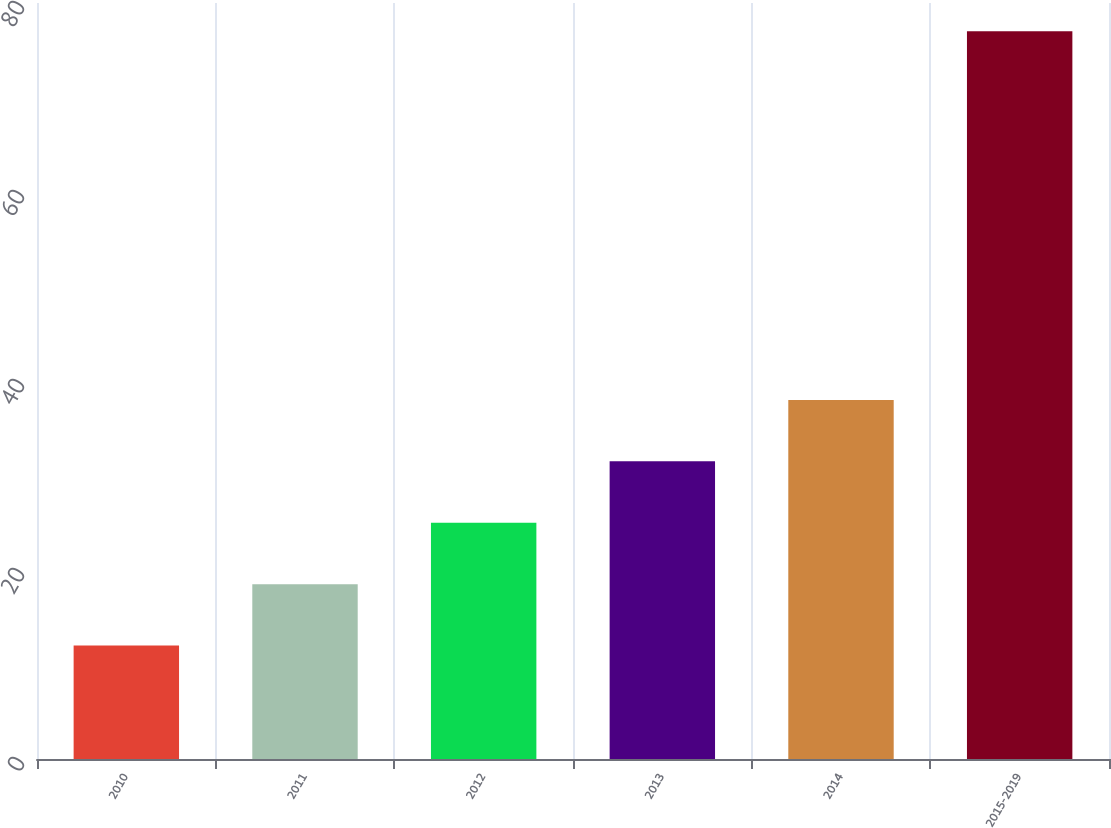<chart> <loc_0><loc_0><loc_500><loc_500><bar_chart><fcel>2010<fcel>2011<fcel>2012<fcel>2013<fcel>2014<fcel>2015-2019<nl><fcel>12<fcel>18.5<fcel>25<fcel>31.5<fcel>38<fcel>77<nl></chart> 